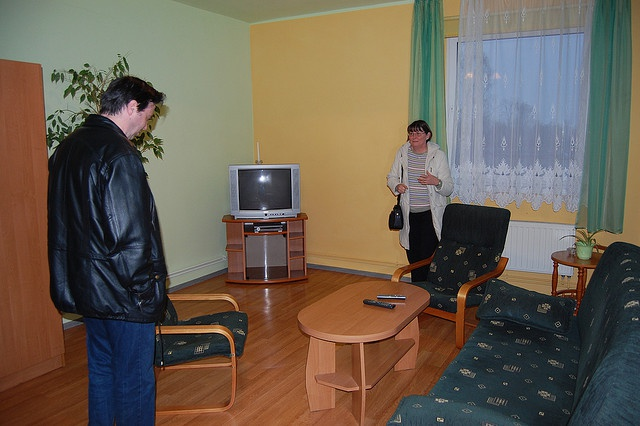Describe the objects in this image and their specific colors. I can see people in gray, black, navy, and darkblue tones, couch in gray, black, blue, and darkblue tones, dining table in gray, brown, salmon, and maroon tones, chair in gray, black, maroon, and brown tones, and people in gray, darkgray, black, and brown tones in this image. 